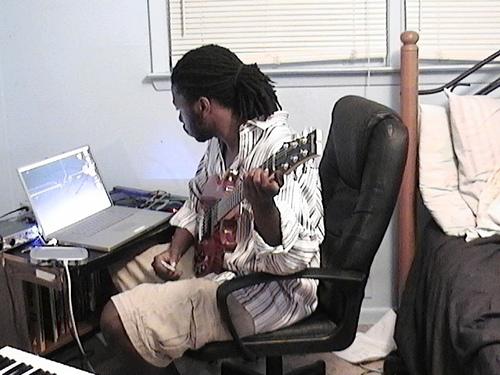What is the guy looking at?
Be succinct. Laptop screen. What is the man holding?
Keep it brief. Guitar. What material is the chair made of?
Be succinct. Leather. 